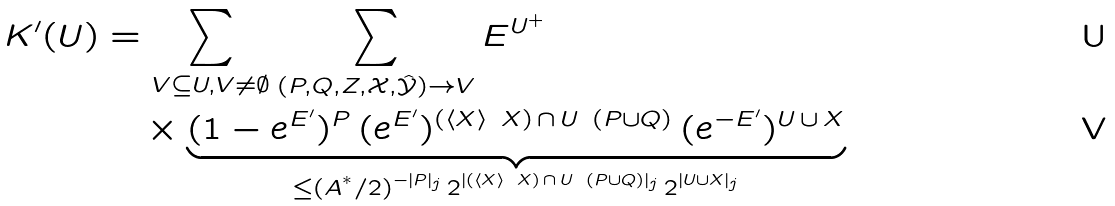Convert formula to latex. <formula><loc_0><loc_0><loc_500><loc_500>K ^ { \prime } ( U ) & = \sum _ { V \subseteq U , V \neq \emptyset } \sum _ { ( P , Q , Z , \mathcal { X } , \hat { \mathcal { Y } } ) \rightarrow V } E ^ { U ^ { + } } \\ & \quad \times \underbrace { ( 1 - e ^ { E ^ { \prime } } ) ^ { P } \, ( e ^ { E ^ { \prime } } ) ^ { ( \left \langle X \right \rangle \ X ) \, \cap \, U \ ( P \cup Q ) } \, ( e ^ { - E ^ { \prime } } ) ^ { U \, \cup \, X } } _ { \leq ( A ^ { ^ { * } } / 2 ) ^ { - | P | _ { j } } \, 2 ^ { | ( \left \langle X \right \rangle \ X ) \, \cap \, U \ ( P \cup Q ) | _ { j } } \, 2 ^ { | U \cup X | _ { j } } }</formula> 